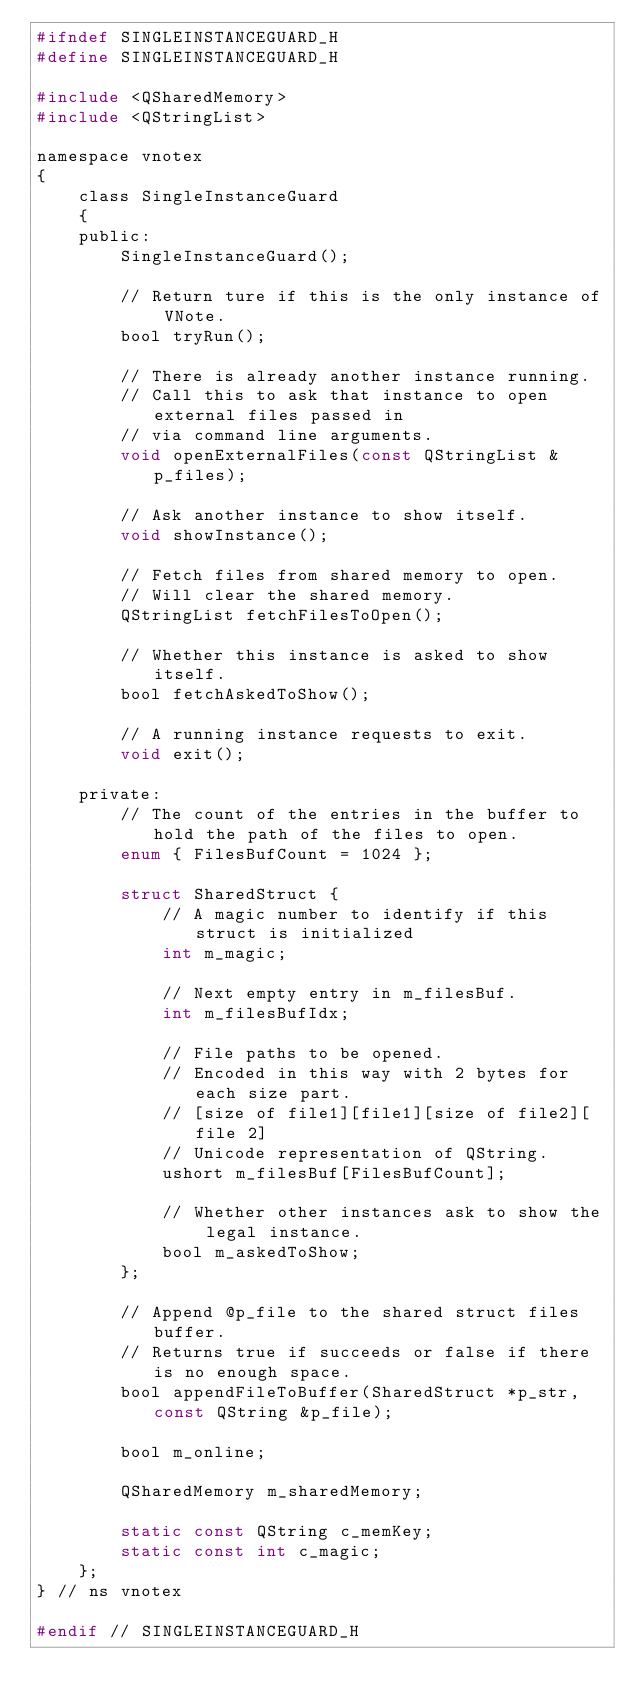<code> <loc_0><loc_0><loc_500><loc_500><_C_>#ifndef SINGLEINSTANCEGUARD_H
#define SINGLEINSTANCEGUARD_H

#include <QSharedMemory>
#include <QStringList>

namespace vnotex
{
    class SingleInstanceGuard
    {
    public:
        SingleInstanceGuard();

        // Return ture if this is the only instance of VNote.
        bool tryRun();

        // There is already another instance running.
        // Call this to ask that instance to open external files passed in
        // via command line arguments.
        void openExternalFiles(const QStringList &p_files);

        // Ask another instance to show itself.
        void showInstance();

        // Fetch files from shared memory to open.
        // Will clear the shared memory.
        QStringList fetchFilesToOpen();

        // Whether this instance is asked to show itself.
        bool fetchAskedToShow();

        // A running instance requests to exit.
        void exit();

    private:
        // The count of the entries in the buffer to hold the path of the files to open.
        enum { FilesBufCount = 1024 };

        struct SharedStruct {
            // A magic number to identify if this struct is initialized
            int m_magic;

            // Next empty entry in m_filesBuf.
            int m_filesBufIdx;

            // File paths to be opened.
            // Encoded in this way with 2 bytes for each size part.
            // [size of file1][file1][size of file2][file 2]
            // Unicode representation of QString.
            ushort m_filesBuf[FilesBufCount];

            // Whether other instances ask to show the legal instance.
            bool m_askedToShow;
        };

        // Append @p_file to the shared struct files buffer.
        // Returns true if succeeds or false if there is no enough space.
        bool appendFileToBuffer(SharedStruct *p_str, const QString &p_file);

        bool m_online;

        QSharedMemory m_sharedMemory;

        static const QString c_memKey;
        static const int c_magic;
    };
} // ns vnotex

#endif // SINGLEINSTANCEGUARD_H
</code> 